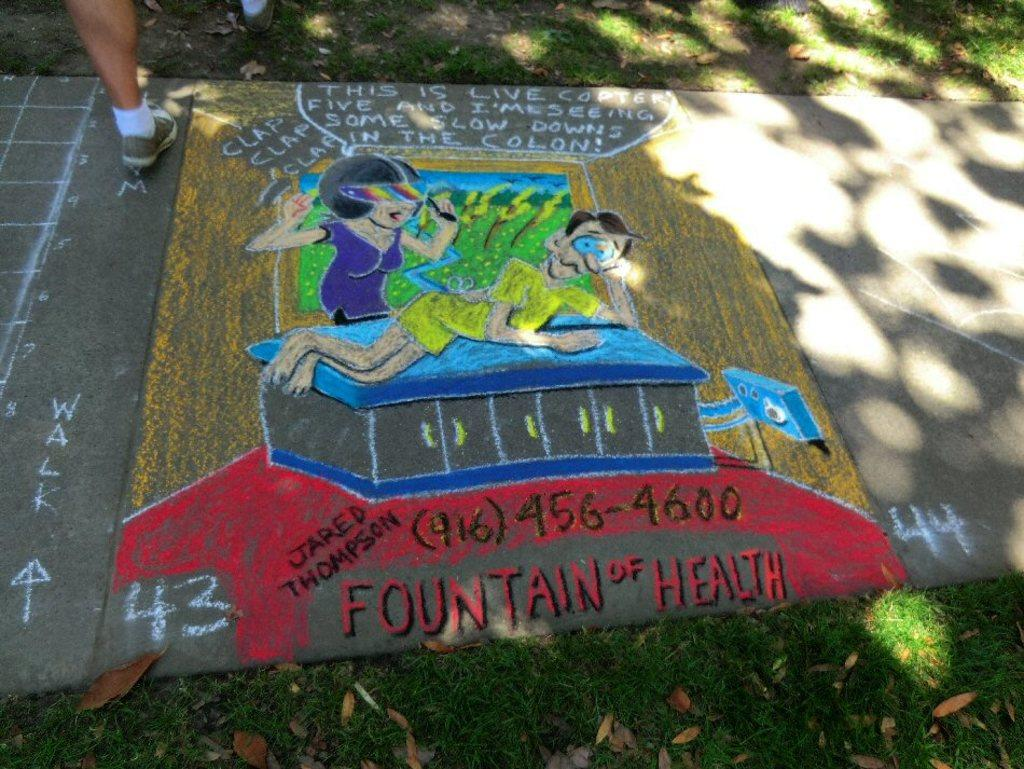What is on the ground in the image? There is a painting on the ground in the image. Can you describe any other elements in the image? A person's leg is visible in the image. What type of boot is the person wearing in the image? There is no boot visible in the image; only a person's leg is visible. Can you tell me how many chin-ups the person is doing in the image? There is no chin-up activity depicted in the image; the person's leg is simply visible. 